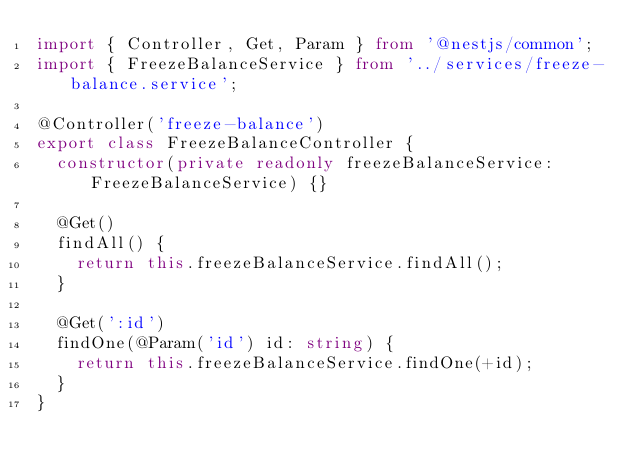<code> <loc_0><loc_0><loc_500><loc_500><_TypeScript_>import { Controller, Get, Param } from '@nestjs/common';
import { FreezeBalanceService } from '../services/freeze-balance.service';

@Controller('freeze-balance')
export class FreezeBalanceController {
  constructor(private readonly freezeBalanceService: FreezeBalanceService) {}

  @Get()
  findAll() {
    return this.freezeBalanceService.findAll();
  }

  @Get(':id')
  findOne(@Param('id') id: string) {
    return this.freezeBalanceService.findOne(+id);
  }
}
</code> 